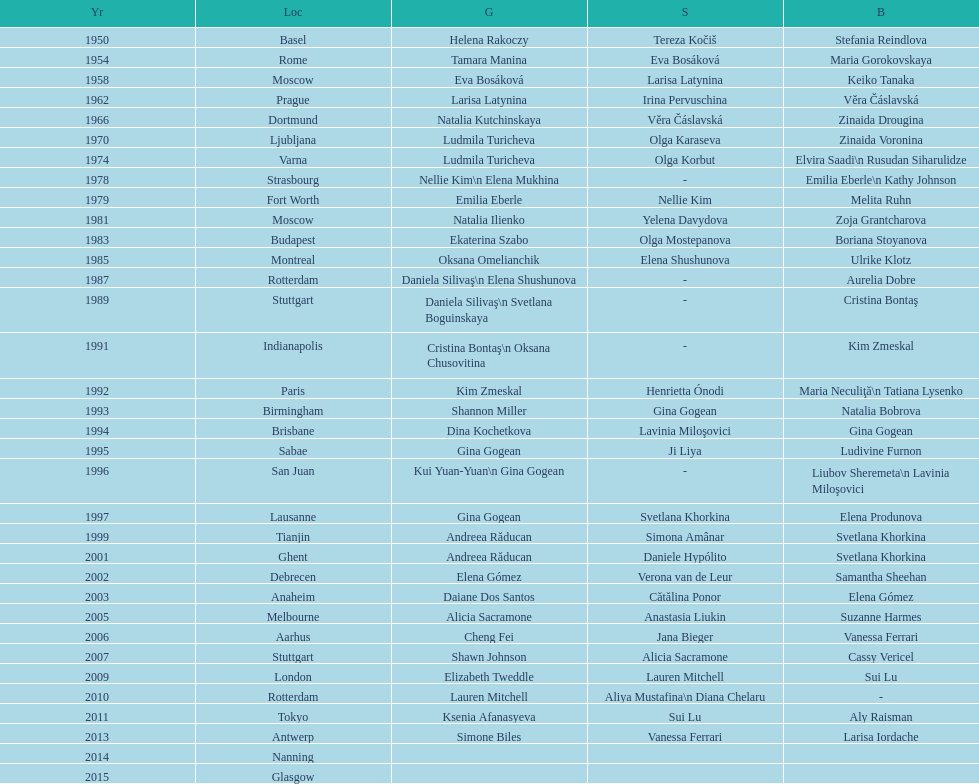As of 2013, what is the total number of floor exercise gold medals won by american women at the world championships? 5. 